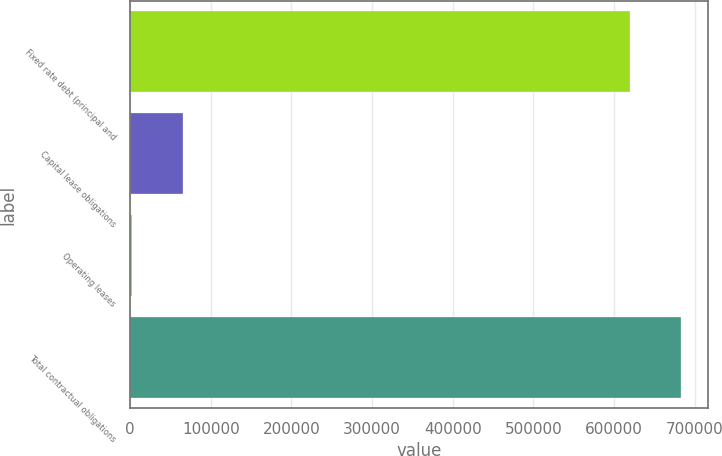Convert chart. <chart><loc_0><loc_0><loc_500><loc_500><bar_chart><fcel>Fixed rate debt (principal and<fcel>Capital lease obligations<fcel>Operating leases<fcel>Total contractual obligations<nl><fcel>619858<fcel>65665.4<fcel>2556<fcel>682967<nl></chart> 